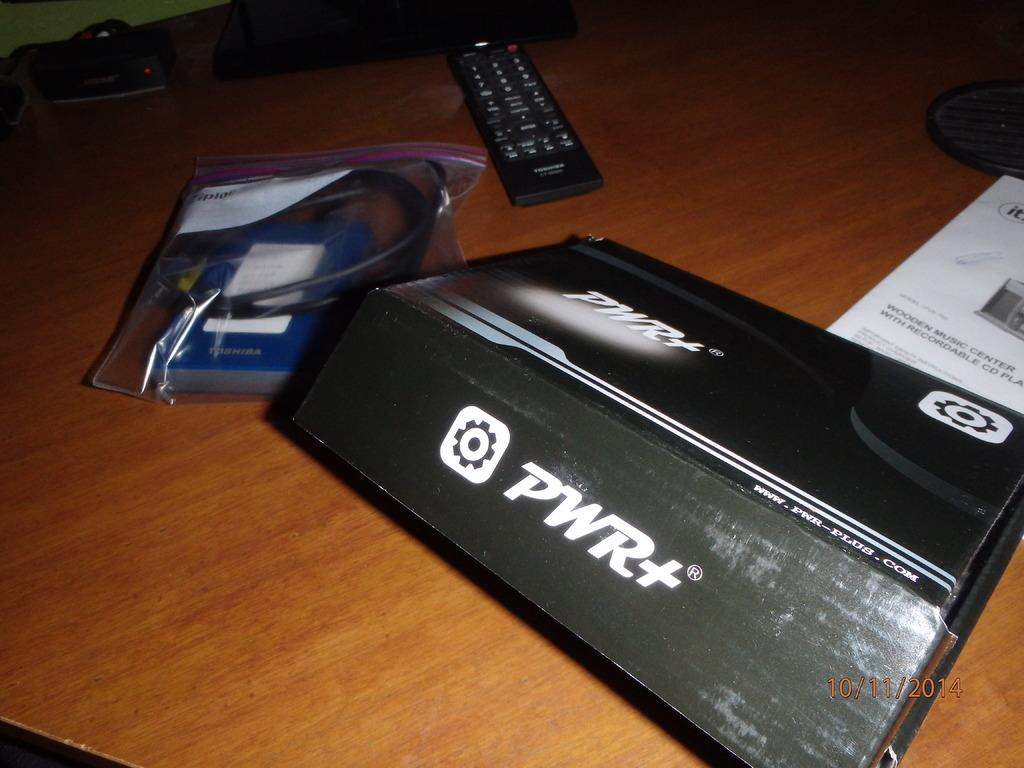Provide a one-sentence caption for the provided image. Box for a PWR+ sits on a table next to directions and a remote. 